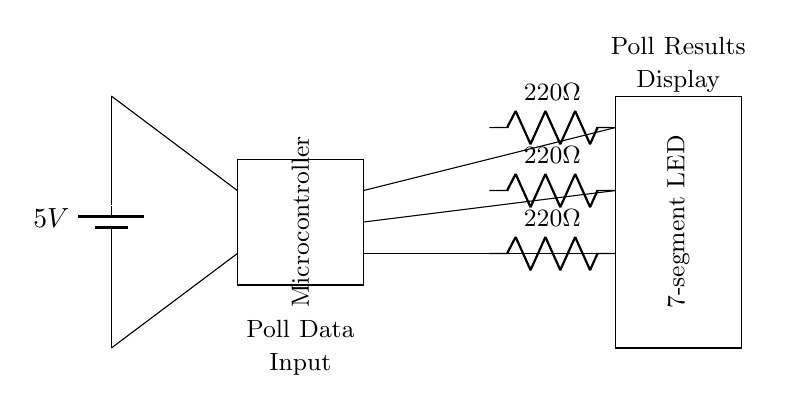What is the voltage of this circuit? The voltage is 5V, as indicated by the label on the battery in the diagram. The battery provides a consistent voltage to power the circuit.
Answer: 5V What type of display is being used to show poll results? The circuit diagram uses a 7-segment LED display, as labeled in the diagram. This type of display is commonly used for numerical representation and is suitable for showing poll results.
Answer: 7-segment LED How many resistors are present in this circuit? There are three resistors shown in the circuit diagram, each marked with the same resistance value of 220 ohms. They are used to limit the current to the LED segments.
Answer: 3 What is the resistance value of each resistor? Each resistor has a resistance value of 220 ohms, indicated next to each resistor in the diagram. This ensures proper current flow through the display without causing damage to the LEDs.
Answer: 220 ohms Which component acts as the control unit for the circuit? The control unit is the microcontroller, which is represented in the diagram. It is responsible for processing the poll data and driving the display accordingly.
Answer: Microcontroller What is the function of the connections between the microcontroller and the LED display? The connections allow data and control signals to be sent from the microcontroller to the LED display, enabling it to visualize the poll results based on the inputs received from the microcontroller.
Answer: Data and control signals 